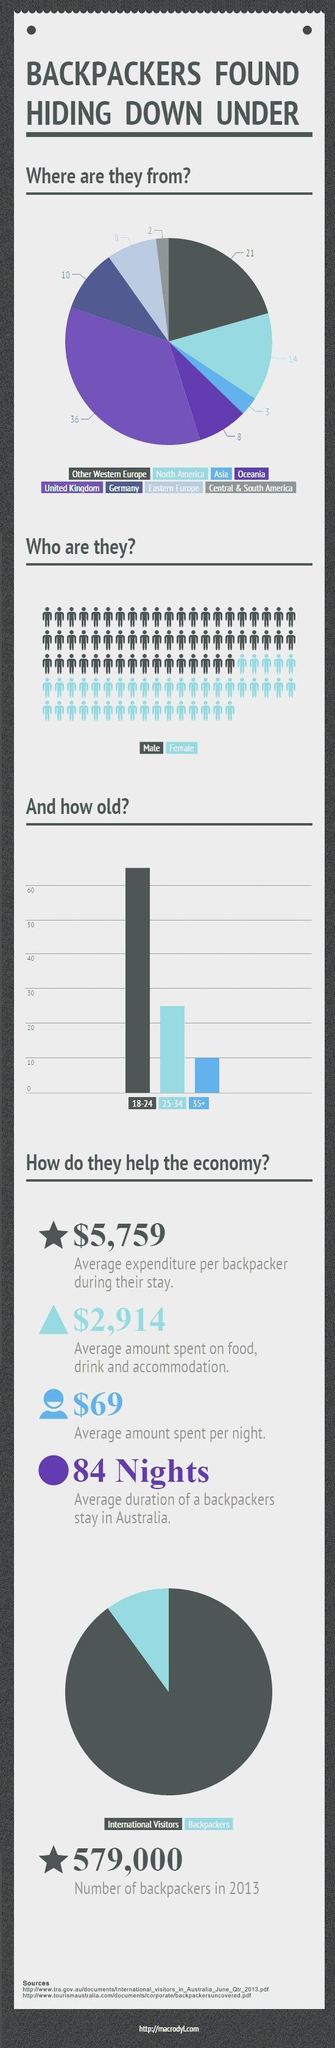Which gender is more in backpacking?
Answer the question with a short phrase. Male How many backpackers come from North America? 14 How many sources are listed? 2 For which age group is backpacking least preferred? 35+ In total what amount in average is spent by a backpacker during stay as well as food, drink and accommodation? $8,673 Where do most number of backpackers come from? United Kingdom 